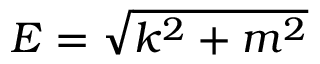Convert formula to latex. <formula><loc_0><loc_0><loc_500><loc_500>E = { \sqrt { k ^ { 2 } + m ^ { 2 } } }</formula> 